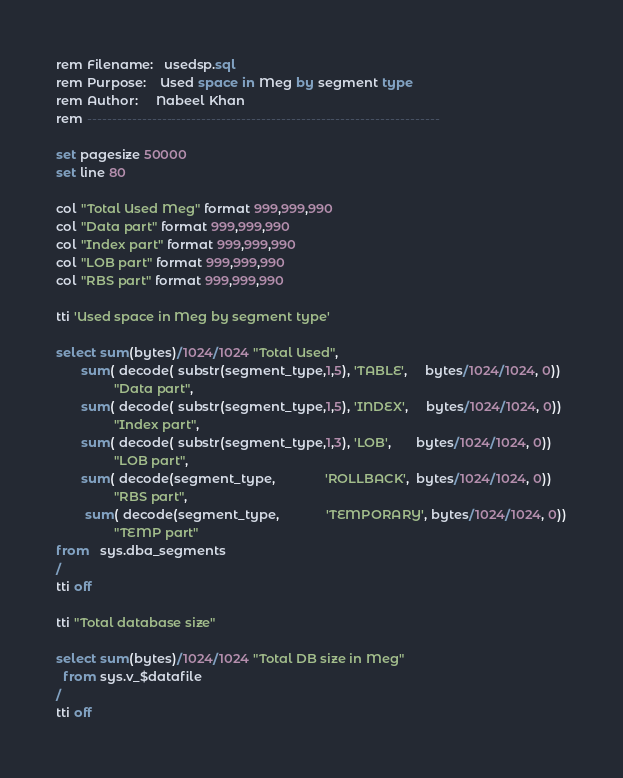Convert code to text. <code><loc_0><loc_0><loc_500><loc_500><_SQL_>rem Filename:   usedsp.sql
rem Purpose:    Used space in Meg by segment type
rem Author:     Nabeel Khan
rem -----------------------------------------------------------------------

set pagesize 50000
set line 80

col "Total Used Meg" format 999,999,990
col "Data part" format 999,999,990
col "Index part" format 999,999,990
col "LOB part" format 999,999,990
col "RBS part" format 999,999,990

tti 'Used space in Meg by segment type'

select sum(bytes)/1024/1024 "Total Used",
       sum( decode( substr(segment_type,1,5), 'TABLE',     bytes/1024/1024, 0))
                "Data part",
       sum( decode( substr(segment_type,1,5), 'INDEX',     bytes/1024/1024, 0))
                "Index part",
       sum( decode( substr(segment_type,1,3), 'LOB',       bytes/1024/1024, 0))
                "LOB part",
       sum( decode(segment_type,              'ROLLBACK',  bytes/1024/1024, 0))
                "RBS part",
        sum( decode(segment_type,             'TEMPORARY', bytes/1024/1024, 0))
                "TEMP part"
from   sys.dba_segments
/
tti off

tti "Total database size"

select sum(bytes)/1024/1024 "Total DB size in Meg"
  from sys.v_$datafile
/
tti off
</code> 